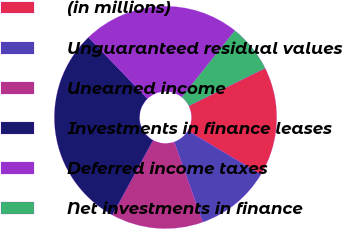Convert chart. <chart><loc_0><loc_0><loc_500><loc_500><pie_chart><fcel>(in millions)<fcel>Unguaranteed residual values<fcel>Unearned income<fcel>Investments in finance leases<fcel>Deferred income taxes<fcel>Net investments in finance<nl><fcel>15.87%<fcel>10.99%<fcel>13.37%<fcel>29.88%<fcel>22.89%<fcel>6.99%<nl></chart> 